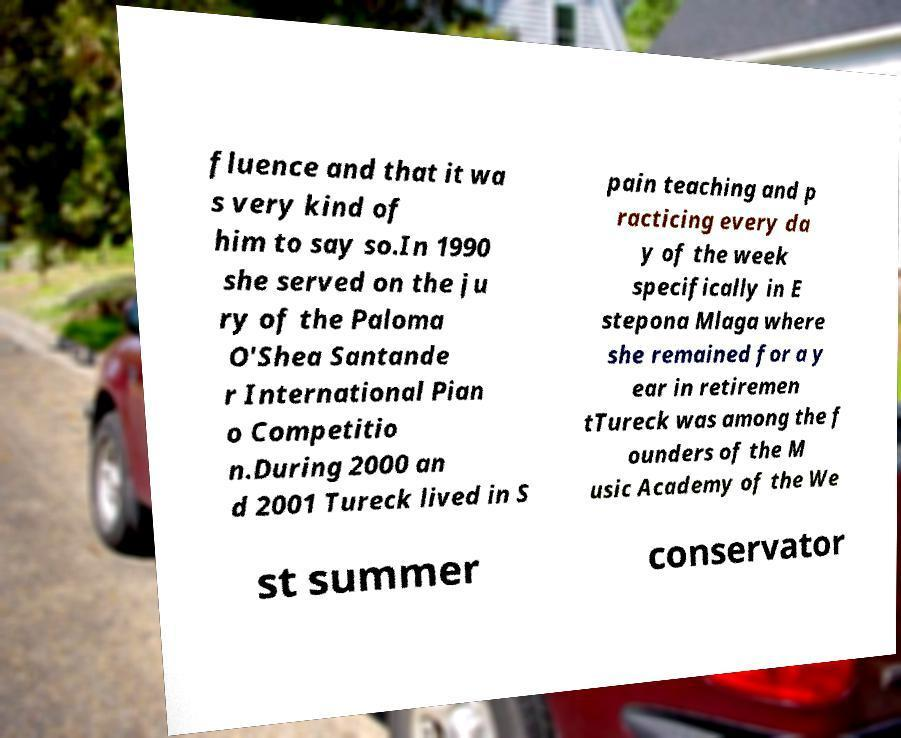Could you assist in decoding the text presented in this image and type it out clearly? fluence and that it wa s very kind of him to say so.In 1990 she served on the ju ry of the Paloma O'Shea Santande r International Pian o Competitio n.During 2000 an d 2001 Tureck lived in S pain teaching and p racticing every da y of the week specifically in E stepona Mlaga where she remained for a y ear in retiremen tTureck was among the f ounders of the M usic Academy of the We st summer conservator 